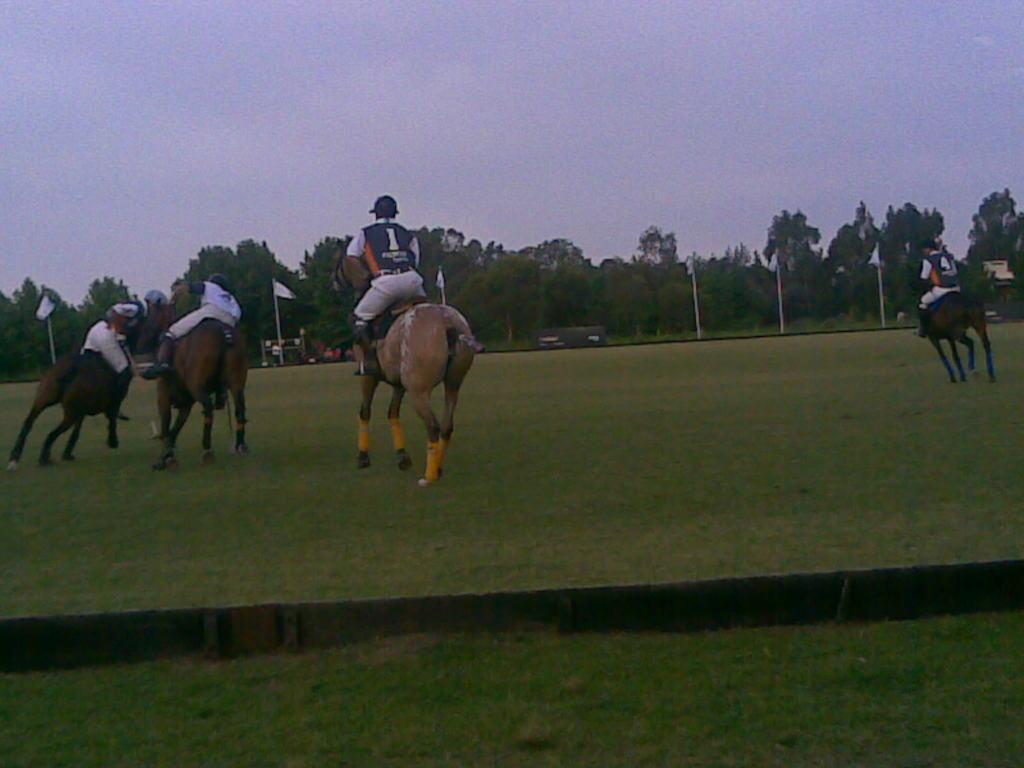Please provide a concise description of this image. In this picture we can see a group of people riding the horses on the grass. In front of the people there is a board, poles with flags, trees and the sky. 